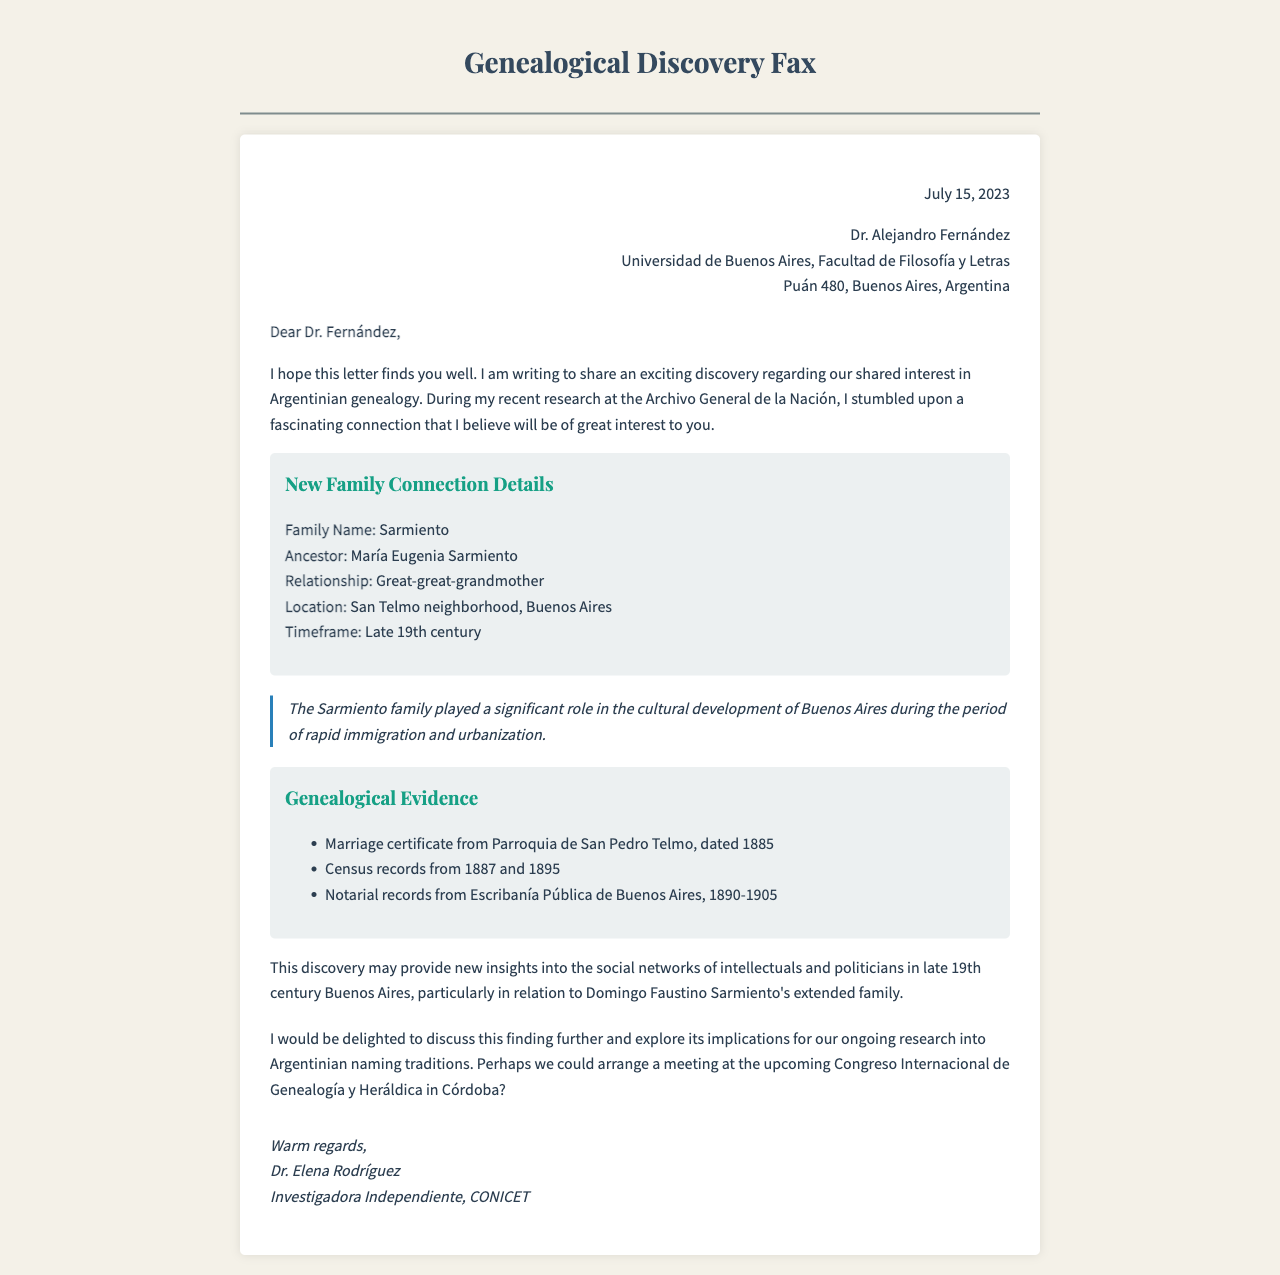What is the name of the ancestor? The ancestor mentioned in the document is María Eugenia Sarmiento.
Answer: María Eugenia Sarmiento What is the relationship to the writer? The document states that María Eugenia Sarmiento is the great-great-grandmother.
Answer: Great-great-grandmother Where was the family connection discovered? The letter indicates that the discovery was made in the San Telmo neighborhood of Buenos Aires.
Answer: San Telmo neighborhood, Buenos Aires What year is the marriage certificate dated? The marriage certificate referenced in the letter is dated 1885.
Answer: 1885 What significant role did the Sarmiento family play? The document explains that the Sarmiento family contributed to the cultural development of Buenos Aires during a specific historical period.
Answer: Cultural development of Buenos Aires What was the timeframe mentioned for the ancestor? The timeframe specified for María Eugenia Sarmiento is the late 19th century.
Answer: Late 19th century What type of records are cited as genealogical evidence? The letter lists several types of records, including marriage certificates, census records, and notarial records.
Answer: Marriage certificate, census records, notarial records Who is the author of the letter? The letter is authored by Dr. Elena Rodríguez.
Answer: Dr. Elena Rodríguez What event is proposed for further discussion of the findings? The document suggests arranging a meeting at the upcoming Congreso Internacional de Genealogía y Heráldica.
Answer: Congreso Internacional de Genealogía y Heráldica 